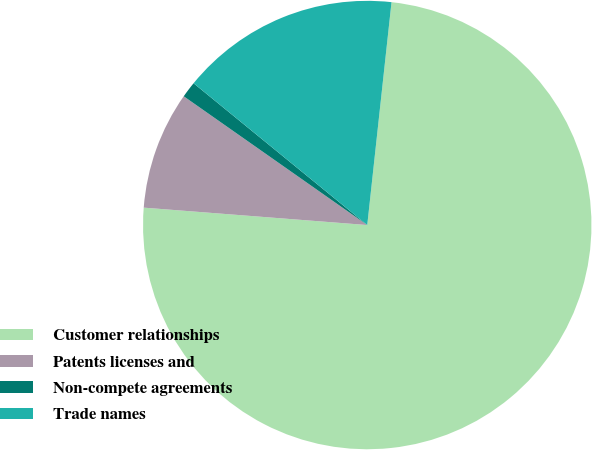<chart> <loc_0><loc_0><loc_500><loc_500><pie_chart><fcel>Customer relationships<fcel>Patents licenses and<fcel>Non-compete agreements<fcel>Trade names<nl><fcel>74.51%<fcel>8.5%<fcel>1.16%<fcel>15.83%<nl></chart> 